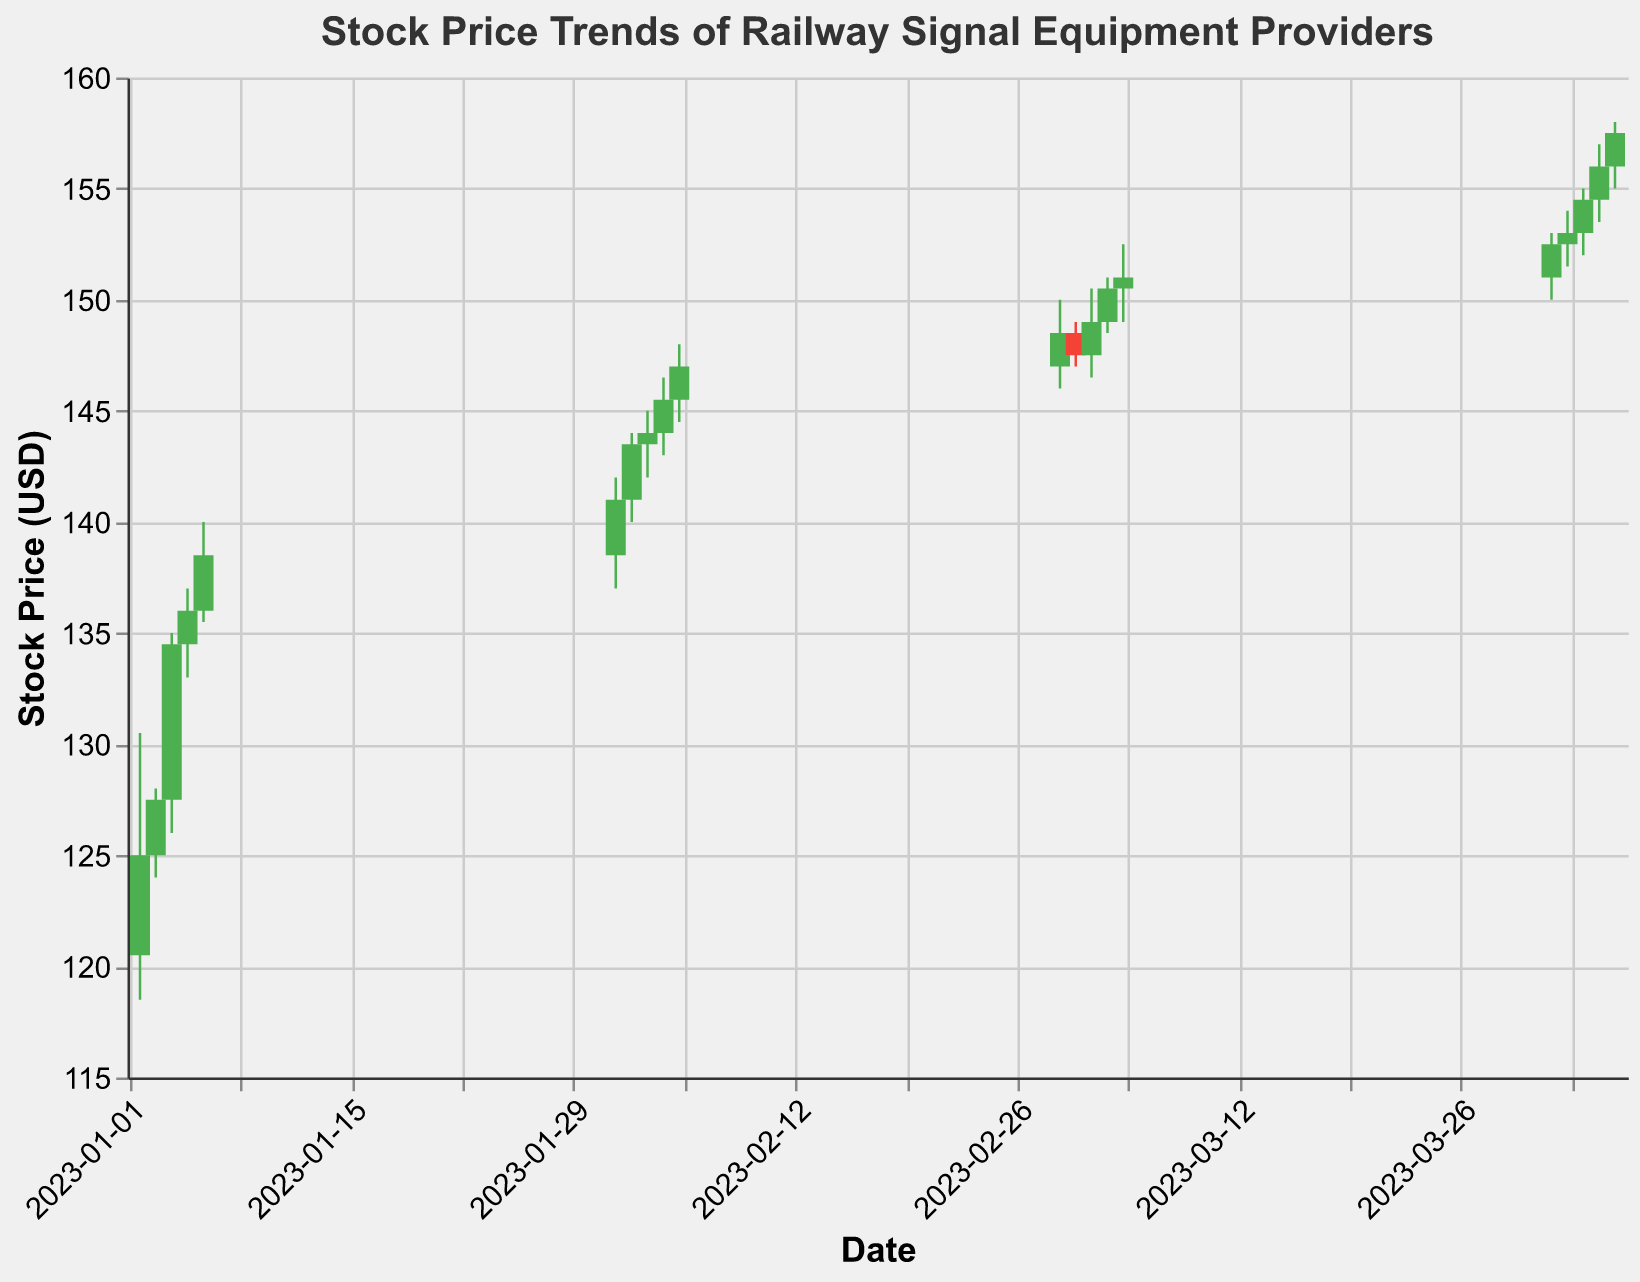What is the title of the figure? The title of the figure is displayed at the top and is "Stock Price Trends of Railway Signal Equipment Providers".
Answer: Stock Price Trends of Railway Signal Equipment Providers Which date had the highest trading volume? Look at the volume values on the y-axis that correspond to the dates. The date with the highest trading volume is April 04, 2023, where the volume reached 1,800,000.
Answer: April 04, 2023 Between February 2023 and March 2023, which month had a higher average closing price? Calculate the average closing prices for all dates in February and March. For February: (141.0+143.5+144.0+145.5+147.0)/5 = 144.2; For March: (148.5+147.5+149.0+150.5+151.0)/5 = 149.3. March had a higher average closing price.
Answer: March 2023 How did the stock price trend change from January 2023 to April 2023? Compare the general direction of the stock prices from the start to the end of each month. January shows a rising trend with the closing prices starting at 125.0 and ending at 138.5. Continuing with an upward trend through February, March, and finally reaching the highest in April with 157.5.
Answer: Increasing Which date had the lowest closing price in January 2023? Review the closing prices for each date in January 2023. The lowest closing price was at the beginning of January on January 02, 2023, with a value of 125.0.
Answer: January 02, 2023 What is the difference between the highest and lowest stock prices for February 2023? Identify the highest and lowest prices in February 2023. The highest is 148.0 on February 05, 2023, and the lowest is 137.0 on February 01, 2023. The difference is 148.0 - 137.0 = 11.0.
Answer: 11.0 If the closing price was higher than the opening price, what color is the bar? In the given plot, if the closing price is higher than the opening price, the bar is colored green.
Answer: Green How many times did the stock close higher than it opened in March 2023? Check the conditions where the closing price is higher than the opening price for each date in March 2023. The count for March includes dates: March 01, March 04, and March 05 – three instances.
Answer: 3 What was the highest high during the period shown on the chart? Review the highest values from the "High" columns. The highest high during the entire period is 158.0, recorded on April 05, 2023.
Answer: 158.0 